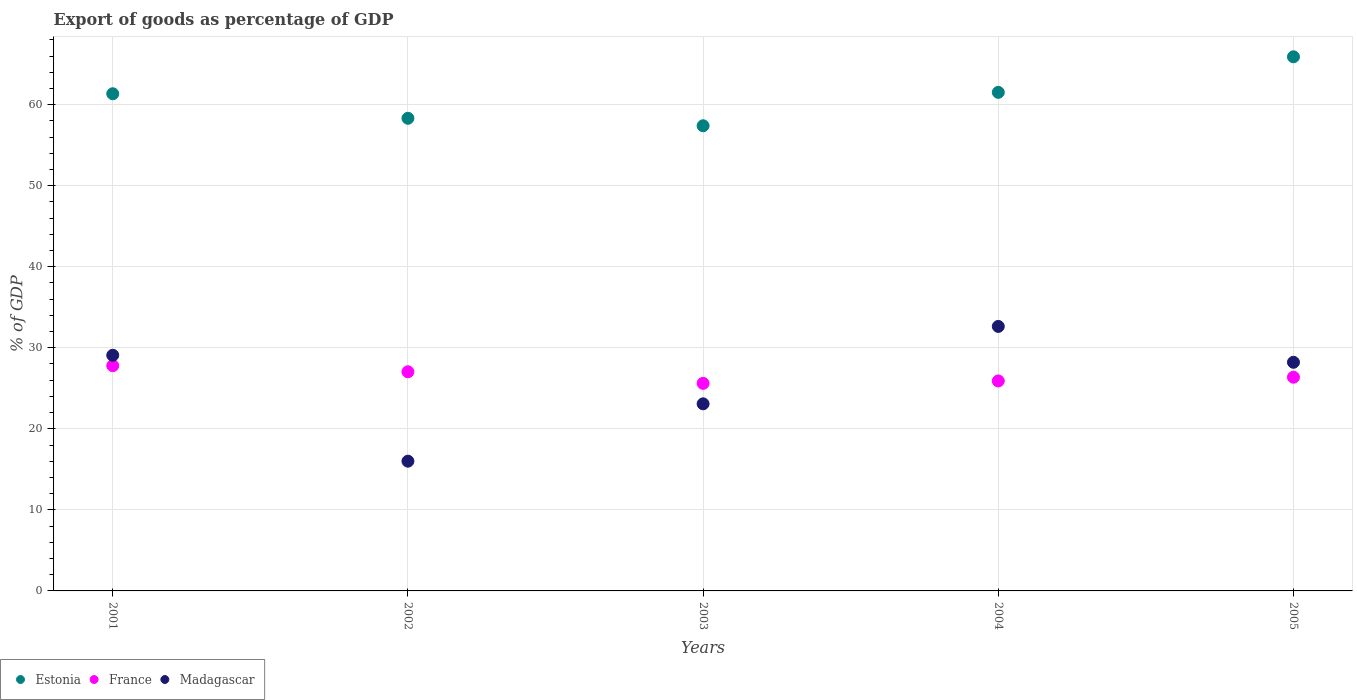Is the number of dotlines equal to the number of legend labels?
Ensure brevity in your answer.  Yes. What is the export of goods as percentage of GDP in Madagascar in 2003?
Ensure brevity in your answer.  23.09. Across all years, what is the maximum export of goods as percentage of GDP in Estonia?
Offer a terse response. 65.91. Across all years, what is the minimum export of goods as percentage of GDP in Madagascar?
Offer a very short reply. 16.01. In which year was the export of goods as percentage of GDP in France maximum?
Keep it short and to the point. 2001. What is the total export of goods as percentage of GDP in Estonia in the graph?
Make the answer very short. 304.48. What is the difference between the export of goods as percentage of GDP in France in 2003 and that in 2004?
Make the answer very short. -0.3. What is the difference between the export of goods as percentage of GDP in Estonia in 2004 and the export of goods as percentage of GDP in Madagascar in 2001?
Provide a short and direct response. 32.44. What is the average export of goods as percentage of GDP in Estonia per year?
Give a very brief answer. 60.9. In the year 2005, what is the difference between the export of goods as percentage of GDP in France and export of goods as percentage of GDP in Estonia?
Your answer should be very brief. -39.54. What is the ratio of the export of goods as percentage of GDP in France in 2004 to that in 2005?
Keep it short and to the point. 0.98. Is the export of goods as percentage of GDP in Estonia in 2001 less than that in 2005?
Make the answer very short. Yes. What is the difference between the highest and the second highest export of goods as percentage of GDP in Estonia?
Provide a succinct answer. 4.39. What is the difference between the highest and the lowest export of goods as percentage of GDP in Madagascar?
Your response must be concise. 16.63. Does the export of goods as percentage of GDP in Estonia monotonically increase over the years?
Ensure brevity in your answer.  No. Does the graph contain any zero values?
Give a very brief answer. No. Does the graph contain grids?
Keep it short and to the point. Yes. How many legend labels are there?
Provide a succinct answer. 3. What is the title of the graph?
Offer a terse response. Export of goods as percentage of GDP. Does "Hungary" appear as one of the legend labels in the graph?
Keep it short and to the point. No. What is the label or title of the Y-axis?
Make the answer very short. % of GDP. What is the % of GDP of Estonia in 2001?
Give a very brief answer. 61.35. What is the % of GDP of France in 2001?
Ensure brevity in your answer.  27.79. What is the % of GDP in Madagascar in 2001?
Provide a short and direct response. 29.08. What is the % of GDP of Estonia in 2002?
Provide a succinct answer. 58.32. What is the % of GDP of France in 2002?
Your answer should be compact. 27.04. What is the % of GDP in Madagascar in 2002?
Your answer should be compact. 16.01. What is the % of GDP of Estonia in 2003?
Offer a very short reply. 57.4. What is the % of GDP of France in 2003?
Give a very brief answer. 25.61. What is the % of GDP of Madagascar in 2003?
Make the answer very short. 23.09. What is the % of GDP of Estonia in 2004?
Provide a short and direct response. 61.52. What is the % of GDP in France in 2004?
Give a very brief answer. 25.91. What is the % of GDP of Madagascar in 2004?
Provide a succinct answer. 32.64. What is the % of GDP in Estonia in 2005?
Make the answer very short. 65.91. What is the % of GDP in France in 2005?
Make the answer very short. 26.37. What is the % of GDP of Madagascar in 2005?
Offer a terse response. 28.21. Across all years, what is the maximum % of GDP of Estonia?
Give a very brief answer. 65.91. Across all years, what is the maximum % of GDP of France?
Provide a succinct answer. 27.79. Across all years, what is the maximum % of GDP of Madagascar?
Give a very brief answer. 32.64. Across all years, what is the minimum % of GDP in Estonia?
Provide a short and direct response. 57.4. Across all years, what is the minimum % of GDP in France?
Your response must be concise. 25.61. Across all years, what is the minimum % of GDP in Madagascar?
Provide a short and direct response. 16.01. What is the total % of GDP of Estonia in the graph?
Ensure brevity in your answer.  304.48. What is the total % of GDP in France in the graph?
Offer a very short reply. 132.72. What is the total % of GDP of Madagascar in the graph?
Ensure brevity in your answer.  129.02. What is the difference between the % of GDP of Estonia in 2001 and that in 2002?
Keep it short and to the point. 3.03. What is the difference between the % of GDP of France in 2001 and that in 2002?
Provide a short and direct response. 0.75. What is the difference between the % of GDP of Madagascar in 2001 and that in 2002?
Your response must be concise. 13.07. What is the difference between the % of GDP in Estonia in 2001 and that in 2003?
Give a very brief answer. 3.95. What is the difference between the % of GDP in France in 2001 and that in 2003?
Your response must be concise. 2.18. What is the difference between the % of GDP of Madagascar in 2001 and that in 2003?
Your answer should be very brief. 5.99. What is the difference between the % of GDP of Estonia in 2001 and that in 2004?
Keep it short and to the point. -0.17. What is the difference between the % of GDP of France in 2001 and that in 2004?
Keep it short and to the point. 1.89. What is the difference between the % of GDP in Madagascar in 2001 and that in 2004?
Your answer should be compact. -3.56. What is the difference between the % of GDP in Estonia in 2001 and that in 2005?
Make the answer very short. -4.56. What is the difference between the % of GDP of France in 2001 and that in 2005?
Your answer should be very brief. 1.43. What is the difference between the % of GDP in Madagascar in 2001 and that in 2005?
Make the answer very short. 0.87. What is the difference between the % of GDP of Estonia in 2002 and that in 2003?
Your answer should be very brief. 0.92. What is the difference between the % of GDP of France in 2002 and that in 2003?
Provide a short and direct response. 1.43. What is the difference between the % of GDP in Madagascar in 2002 and that in 2003?
Offer a very short reply. -7.08. What is the difference between the % of GDP in Estonia in 2002 and that in 2004?
Your answer should be compact. -3.2. What is the difference between the % of GDP in France in 2002 and that in 2004?
Your answer should be compact. 1.13. What is the difference between the % of GDP in Madagascar in 2002 and that in 2004?
Your response must be concise. -16.63. What is the difference between the % of GDP in Estonia in 2002 and that in 2005?
Your answer should be very brief. -7.59. What is the difference between the % of GDP of France in 2002 and that in 2005?
Provide a short and direct response. 0.67. What is the difference between the % of GDP in Madagascar in 2002 and that in 2005?
Provide a succinct answer. -12.2. What is the difference between the % of GDP in Estonia in 2003 and that in 2004?
Offer a very short reply. -4.12. What is the difference between the % of GDP in France in 2003 and that in 2004?
Offer a terse response. -0.3. What is the difference between the % of GDP of Madagascar in 2003 and that in 2004?
Your answer should be compact. -9.55. What is the difference between the % of GDP in Estonia in 2003 and that in 2005?
Your response must be concise. -8.51. What is the difference between the % of GDP in France in 2003 and that in 2005?
Offer a very short reply. -0.76. What is the difference between the % of GDP in Madagascar in 2003 and that in 2005?
Provide a succinct answer. -5.13. What is the difference between the % of GDP in Estonia in 2004 and that in 2005?
Give a very brief answer. -4.39. What is the difference between the % of GDP of France in 2004 and that in 2005?
Your response must be concise. -0.46. What is the difference between the % of GDP in Madagascar in 2004 and that in 2005?
Ensure brevity in your answer.  4.42. What is the difference between the % of GDP in Estonia in 2001 and the % of GDP in France in 2002?
Keep it short and to the point. 34.31. What is the difference between the % of GDP of Estonia in 2001 and the % of GDP of Madagascar in 2002?
Your answer should be very brief. 45.34. What is the difference between the % of GDP of France in 2001 and the % of GDP of Madagascar in 2002?
Ensure brevity in your answer.  11.79. What is the difference between the % of GDP in Estonia in 2001 and the % of GDP in France in 2003?
Provide a succinct answer. 35.74. What is the difference between the % of GDP in Estonia in 2001 and the % of GDP in Madagascar in 2003?
Keep it short and to the point. 38.26. What is the difference between the % of GDP of France in 2001 and the % of GDP of Madagascar in 2003?
Provide a succinct answer. 4.71. What is the difference between the % of GDP of Estonia in 2001 and the % of GDP of France in 2004?
Your answer should be compact. 35.44. What is the difference between the % of GDP of Estonia in 2001 and the % of GDP of Madagascar in 2004?
Provide a short and direct response. 28.71. What is the difference between the % of GDP of France in 2001 and the % of GDP of Madagascar in 2004?
Your answer should be very brief. -4.84. What is the difference between the % of GDP of Estonia in 2001 and the % of GDP of France in 2005?
Your answer should be compact. 34.98. What is the difference between the % of GDP in Estonia in 2001 and the % of GDP in Madagascar in 2005?
Offer a terse response. 33.13. What is the difference between the % of GDP in France in 2001 and the % of GDP in Madagascar in 2005?
Give a very brief answer. -0.42. What is the difference between the % of GDP of Estonia in 2002 and the % of GDP of France in 2003?
Provide a short and direct response. 32.71. What is the difference between the % of GDP in Estonia in 2002 and the % of GDP in Madagascar in 2003?
Give a very brief answer. 35.23. What is the difference between the % of GDP in France in 2002 and the % of GDP in Madagascar in 2003?
Give a very brief answer. 3.95. What is the difference between the % of GDP in Estonia in 2002 and the % of GDP in France in 2004?
Offer a terse response. 32.41. What is the difference between the % of GDP of Estonia in 2002 and the % of GDP of Madagascar in 2004?
Make the answer very short. 25.68. What is the difference between the % of GDP of France in 2002 and the % of GDP of Madagascar in 2004?
Your answer should be compact. -5.6. What is the difference between the % of GDP of Estonia in 2002 and the % of GDP of France in 2005?
Provide a short and direct response. 31.95. What is the difference between the % of GDP of Estonia in 2002 and the % of GDP of Madagascar in 2005?
Give a very brief answer. 30.11. What is the difference between the % of GDP of France in 2002 and the % of GDP of Madagascar in 2005?
Your response must be concise. -1.17. What is the difference between the % of GDP in Estonia in 2003 and the % of GDP in France in 2004?
Your answer should be very brief. 31.49. What is the difference between the % of GDP of Estonia in 2003 and the % of GDP of Madagascar in 2004?
Your response must be concise. 24.76. What is the difference between the % of GDP in France in 2003 and the % of GDP in Madagascar in 2004?
Offer a terse response. -7.03. What is the difference between the % of GDP of Estonia in 2003 and the % of GDP of France in 2005?
Your response must be concise. 31.03. What is the difference between the % of GDP of Estonia in 2003 and the % of GDP of Madagascar in 2005?
Your response must be concise. 29.18. What is the difference between the % of GDP in France in 2003 and the % of GDP in Madagascar in 2005?
Your answer should be compact. -2.6. What is the difference between the % of GDP of Estonia in 2004 and the % of GDP of France in 2005?
Your answer should be compact. 35.15. What is the difference between the % of GDP of Estonia in 2004 and the % of GDP of Madagascar in 2005?
Offer a very short reply. 33.31. What is the difference between the % of GDP of France in 2004 and the % of GDP of Madagascar in 2005?
Provide a short and direct response. -2.3. What is the average % of GDP of Estonia per year?
Provide a short and direct response. 60.9. What is the average % of GDP of France per year?
Offer a terse response. 26.54. What is the average % of GDP of Madagascar per year?
Your answer should be compact. 25.8. In the year 2001, what is the difference between the % of GDP in Estonia and % of GDP in France?
Provide a short and direct response. 33.55. In the year 2001, what is the difference between the % of GDP of Estonia and % of GDP of Madagascar?
Your response must be concise. 32.27. In the year 2001, what is the difference between the % of GDP in France and % of GDP in Madagascar?
Your answer should be compact. -1.28. In the year 2002, what is the difference between the % of GDP of Estonia and % of GDP of France?
Give a very brief answer. 31.28. In the year 2002, what is the difference between the % of GDP of Estonia and % of GDP of Madagascar?
Your answer should be compact. 42.31. In the year 2002, what is the difference between the % of GDP in France and % of GDP in Madagascar?
Offer a terse response. 11.03. In the year 2003, what is the difference between the % of GDP of Estonia and % of GDP of France?
Offer a terse response. 31.78. In the year 2003, what is the difference between the % of GDP in Estonia and % of GDP in Madagascar?
Offer a very short reply. 34.31. In the year 2003, what is the difference between the % of GDP in France and % of GDP in Madagascar?
Your response must be concise. 2.53. In the year 2004, what is the difference between the % of GDP in Estonia and % of GDP in France?
Keep it short and to the point. 35.61. In the year 2004, what is the difference between the % of GDP in Estonia and % of GDP in Madagascar?
Your answer should be very brief. 28.88. In the year 2004, what is the difference between the % of GDP in France and % of GDP in Madagascar?
Offer a terse response. -6.73. In the year 2005, what is the difference between the % of GDP of Estonia and % of GDP of France?
Provide a succinct answer. 39.54. In the year 2005, what is the difference between the % of GDP in Estonia and % of GDP in Madagascar?
Your answer should be compact. 37.69. In the year 2005, what is the difference between the % of GDP in France and % of GDP in Madagascar?
Provide a short and direct response. -1.84. What is the ratio of the % of GDP of Estonia in 2001 to that in 2002?
Your answer should be compact. 1.05. What is the ratio of the % of GDP in France in 2001 to that in 2002?
Your answer should be very brief. 1.03. What is the ratio of the % of GDP in Madagascar in 2001 to that in 2002?
Your response must be concise. 1.82. What is the ratio of the % of GDP of Estonia in 2001 to that in 2003?
Make the answer very short. 1.07. What is the ratio of the % of GDP in France in 2001 to that in 2003?
Offer a terse response. 1.09. What is the ratio of the % of GDP of Madagascar in 2001 to that in 2003?
Provide a short and direct response. 1.26. What is the ratio of the % of GDP in France in 2001 to that in 2004?
Your answer should be very brief. 1.07. What is the ratio of the % of GDP of Madagascar in 2001 to that in 2004?
Give a very brief answer. 0.89. What is the ratio of the % of GDP in Estonia in 2001 to that in 2005?
Your answer should be compact. 0.93. What is the ratio of the % of GDP of France in 2001 to that in 2005?
Ensure brevity in your answer.  1.05. What is the ratio of the % of GDP in Madagascar in 2001 to that in 2005?
Offer a very short reply. 1.03. What is the ratio of the % of GDP in Estonia in 2002 to that in 2003?
Provide a short and direct response. 1.02. What is the ratio of the % of GDP in France in 2002 to that in 2003?
Provide a succinct answer. 1.06. What is the ratio of the % of GDP in Madagascar in 2002 to that in 2003?
Offer a very short reply. 0.69. What is the ratio of the % of GDP in Estonia in 2002 to that in 2004?
Make the answer very short. 0.95. What is the ratio of the % of GDP in France in 2002 to that in 2004?
Ensure brevity in your answer.  1.04. What is the ratio of the % of GDP in Madagascar in 2002 to that in 2004?
Keep it short and to the point. 0.49. What is the ratio of the % of GDP of Estonia in 2002 to that in 2005?
Offer a very short reply. 0.88. What is the ratio of the % of GDP in France in 2002 to that in 2005?
Keep it short and to the point. 1.03. What is the ratio of the % of GDP in Madagascar in 2002 to that in 2005?
Give a very brief answer. 0.57. What is the ratio of the % of GDP in Estonia in 2003 to that in 2004?
Your answer should be compact. 0.93. What is the ratio of the % of GDP of Madagascar in 2003 to that in 2004?
Ensure brevity in your answer.  0.71. What is the ratio of the % of GDP of Estonia in 2003 to that in 2005?
Your answer should be compact. 0.87. What is the ratio of the % of GDP in France in 2003 to that in 2005?
Offer a very short reply. 0.97. What is the ratio of the % of GDP of Madagascar in 2003 to that in 2005?
Provide a succinct answer. 0.82. What is the ratio of the % of GDP in Estonia in 2004 to that in 2005?
Your answer should be very brief. 0.93. What is the ratio of the % of GDP in France in 2004 to that in 2005?
Your answer should be compact. 0.98. What is the ratio of the % of GDP of Madagascar in 2004 to that in 2005?
Offer a very short reply. 1.16. What is the difference between the highest and the second highest % of GDP in Estonia?
Offer a very short reply. 4.39. What is the difference between the highest and the second highest % of GDP of France?
Ensure brevity in your answer.  0.75. What is the difference between the highest and the second highest % of GDP in Madagascar?
Provide a succinct answer. 3.56. What is the difference between the highest and the lowest % of GDP of Estonia?
Offer a very short reply. 8.51. What is the difference between the highest and the lowest % of GDP of France?
Provide a short and direct response. 2.18. What is the difference between the highest and the lowest % of GDP in Madagascar?
Ensure brevity in your answer.  16.63. 